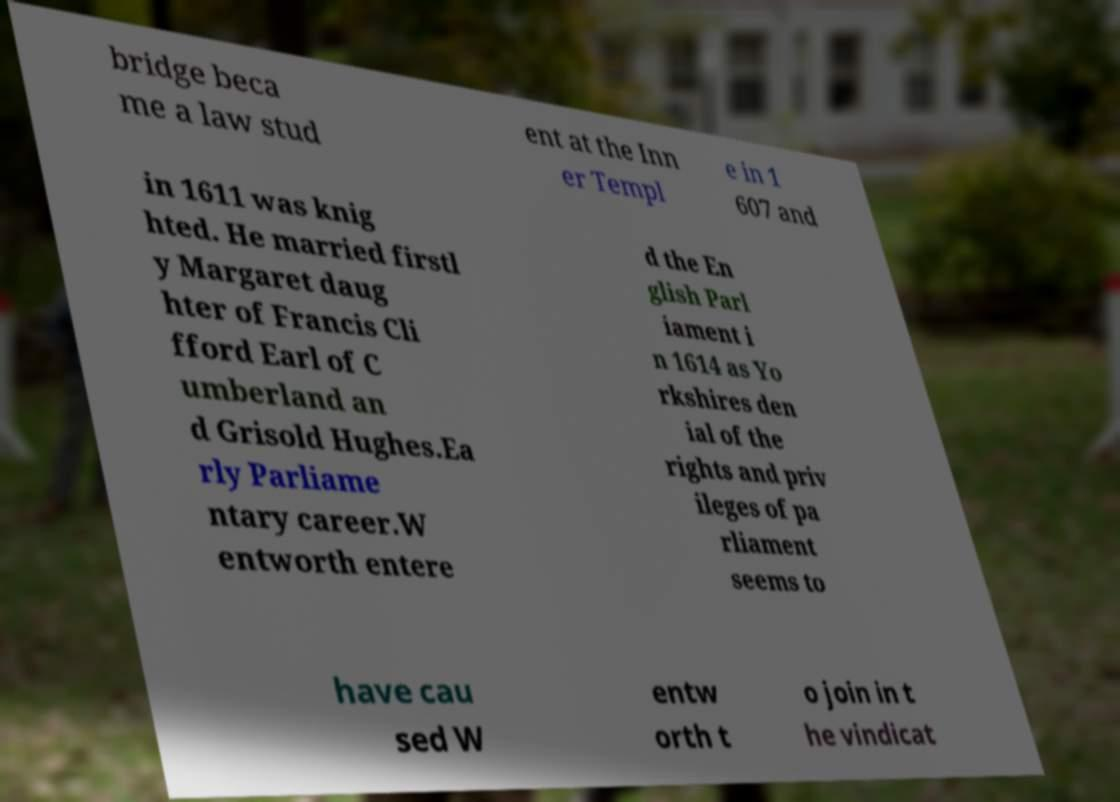I need the written content from this picture converted into text. Can you do that? bridge beca me a law stud ent at the Inn er Templ e in 1 607 and in 1611 was knig hted. He married firstl y Margaret daug hter of Francis Cli fford Earl of C umberland an d Grisold Hughes.Ea rly Parliame ntary career.W entworth entere d the En glish Parl iament i n 1614 as Yo rkshires den ial of the rights and priv ileges of pa rliament seems to have cau sed W entw orth t o join in t he vindicat 